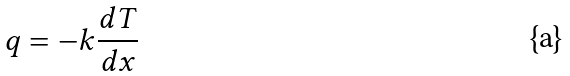Convert formula to latex. <formula><loc_0><loc_0><loc_500><loc_500>q = - k \frac { d T } { d x }</formula> 